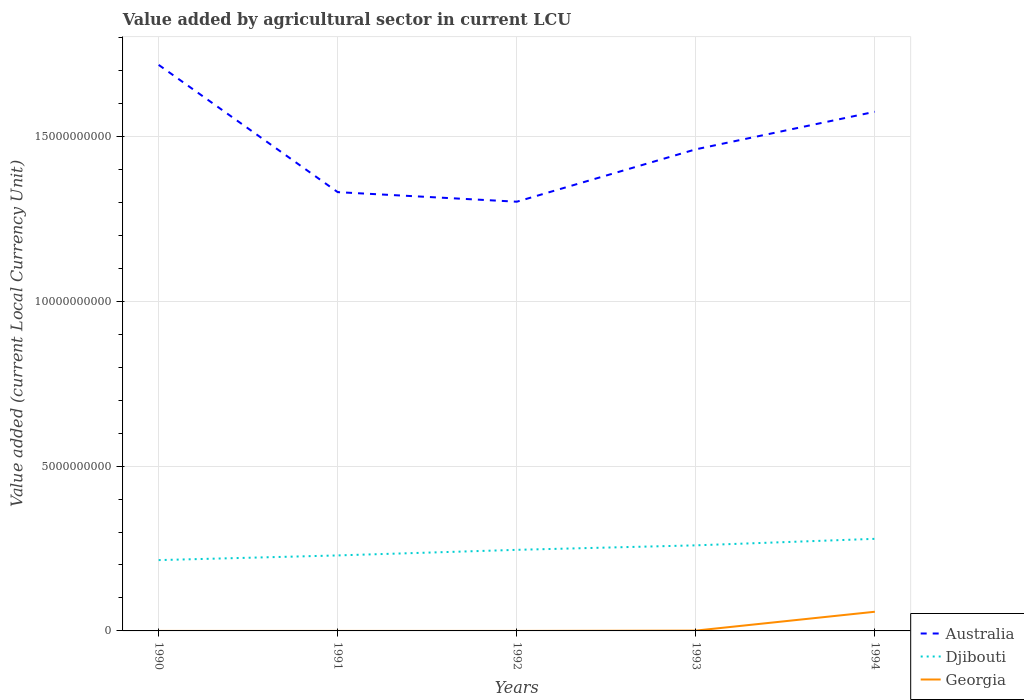How many different coloured lines are there?
Offer a very short reply. 3. Across all years, what is the maximum value added by agricultural sector in Djibouti?
Your answer should be compact. 2.15e+09. What is the total value added by agricultural sector in Georgia in the graph?
Your answer should be very brief. -5.82e+08. What is the difference between the highest and the second highest value added by agricultural sector in Australia?
Your answer should be very brief. 4.15e+09. Is the value added by agricultural sector in Australia strictly greater than the value added by agricultural sector in Djibouti over the years?
Your answer should be compact. No. How many lines are there?
Offer a very short reply. 3. Are the values on the major ticks of Y-axis written in scientific E-notation?
Offer a very short reply. No. Does the graph contain any zero values?
Your answer should be very brief. No. Does the graph contain grids?
Provide a succinct answer. Yes. Where does the legend appear in the graph?
Offer a very short reply. Bottom right. How are the legend labels stacked?
Offer a very short reply. Vertical. What is the title of the graph?
Ensure brevity in your answer.  Value added by agricultural sector in current LCU. Does "Bahrain" appear as one of the legend labels in the graph?
Give a very brief answer. No. What is the label or title of the Y-axis?
Your answer should be compact. Value added (current Local Currency Unit). What is the Value added (current Local Currency Unit) of Australia in 1990?
Ensure brevity in your answer.  1.72e+1. What is the Value added (current Local Currency Unit) in Djibouti in 1990?
Offer a very short reply. 2.15e+09. What is the Value added (current Local Currency Unit) in Georgia in 1990?
Your answer should be very brief. 4500. What is the Value added (current Local Currency Unit) of Australia in 1991?
Your answer should be compact. 1.33e+1. What is the Value added (current Local Currency Unit) in Djibouti in 1991?
Ensure brevity in your answer.  2.29e+09. What is the Value added (current Local Currency Unit) in Georgia in 1991?
Give a very brief answer. 5100. What is the Value added (current Local Currency Unit) in Australia in 1992?
Offer a terse response. 1.30e+1. What is the Value added (current Local Currency Unit) in Djibouti in 1992?
Provide a succinct answer. 2.46e+09. What is the Value added (current Local Currency Unit) of Georgia in 1992?
Keep it short and to the point. 7.81e+04. What is the Value added (current Local Currency Unit) in Australia in 1993?
Make the answer very short. 1.46e+1. What is the Value added (current Local Currency Unit) of Djibouti in 1993?
Ensure brevity in your answer.  2.60e+09. What is the Value added (current Local Currency Unit) of Georgia in 1993?
Offer a very short reply. 9.52e+06. What is the Value added (current Local Currency Unit) in Australia in 1994?
Offer a very short reply. 1.57e+1. What is the Value added (current Local Currency Unit) of Djibouti in 1994?
Provide a succinct answer. 2.79e+09. What is the Value added (current Local Currency Unit) in Georgia in 1994?
Your answer should be very brief. 5.82e+08. Across all years, what is the maximum Value added (current Local Currency Unit) in Australia?
Offer a terse response. 1.72e+1. Across all years, what is the maximum Value added (current Local Currency Unit) of Djibouti?
Your answer should be very brief. 2.79e+09. Across all years, what is the maximum Value added (current Local Currency Unit) of Georgia?
Make the answer very short. 5.82e+08. Across all years, what is the minimum Value added (current Local Currency Unit) of Australia?
Provide a succinct answer. 1.30e+1. Across all years, what is the minimum Value added (current Local Currency Unit) in Djibouti?
Offer a very short reply. 2.15e+09. Across all years, what is the minimum Value added (current Local Currency Unit) in Georgia?
Your answer should be compact. 4500. What is the total Value added (current Local Currency Unit) in Australia in the graph?
Your answer should be compact. 7.38e+1. What is the total Value added (current Local Currency Unit) of Djibouti in the graph?
Make the answer very short. 1.23e+1. What is the total Value added (current Local Currency Unit) of Georgia in the graph?
Ensure brevity in your answer.  5.91e+08. What is the difference between the Value added (current Local Currency Unit) of Australia in 1990 and that in 1991?
Offer a very short reply. 3.86e+09. What is the difference between the Value added (current Local Currency Unit) of Djibouti in 1990 and that in 1991?
Your answer should be very brief. -1.42e+08. What is the difference between the Value added (current Local Currency Unit) of Georgia in 1990 and that in 1991?
Offer a very short reply. -600. What is the difference between the Value added (current Local Currency Unit) of Australia in 1990 and that in 1992?
Provide a short and direct response. 4.15e+09. What is the difference between the Value added (current Local Currency Unit) in Djibouti in 1990 and that in 1992?
Make the answer very short. -3.11e+08. What is the difference between the Value added (current Local Currency Unit) in Georgia in 1990 and that in 1992?
Your answer should be very brief. -7.36e+04. What is the difference between the Value added (current Local Currency Unit) in Australia in 1990 and that in 1993?
Provide a succinct answer. 2.56e+09. What is the difference between the Value added (current Local Currency Unit) in Djibouti in 1990 and that in 1993?
Make the answer very short. -4.48e+08. What is the difference between the Value added (current Local Currency Unit) in Georgia in 1990 and that in 1993?
Keep it short and to the point. -9.51e+06. What is the difference between the Value added (current Local Currency Unit) in Australia in 1990 and that in 1994?
Your response must be concise. 1.42e+09. What is the difference between the Value added (current Local Currency Unit) of Djibouti in 1990 and that in 1994?
Your answer should be very brief. -6.45e+08. What is the difference between the Value added (current Local Currency Unit) in Georgia in 1990 and that in 1994?
Ensure brevity in your answer.  -5.82e+08. What is the difference between the Value added (current Local Currency Unit) in Australia in 1991 and that in 1992?
Offer a very short reply. 2.90e+08. What is the difference between the Value added (current Local Currency Unit) in Djibouti in 1991 and that in 1992?
Keep it short and to the point. -1.70e+08. What is the difference between the Value added (current Local Currency Unit) in Georgia in 1991 and that in 1992?
Offer a terse response. -7.30e+04. What is the difference between the Value added (current Local Currency Unit) of Australia in 1991 and that in 1993?
Keep it short and to the point. -1.30e+09. What is the difference between the Value added (current Local Currency Unit) of Djibouti in 1991 and that in 1993?
Your answer should be compact. -3.06e+08. What is the difference between the Value added (current Local Currency Unit) in Georgia in 1991 and that in 1993?
Give a very brief answer. -9.51e+06. What is the difference between the Value added (current Local Currency Unit) of Australia in 1991 and that in 1994?
Make the answer very short. -2.44e+09. What is the difference between the Value added (current Local Currency Unit) in Djibouti in 1991 and that in 1994?
Your answer should be very brief. -5.03e+08. What is the difference between the Value added (current Local Currency Unit) in Georgia in 1991 and that in 1994?
Offer a very short reply. -5.82e+08. What is the difference between the Value added (current Local Currency Unit) in Australia in 1992 and that in 1993?
Make the answer very short. -1.59e+09. What is the difference between the Value added (current Local Currency Unit) of Djibouti in 1992 and that in 1993?
Your answer should be compact. -1.36e+08. What is the difference between the Value added (current Local Currency Unit) of Georgia in 1992 and that in 1993?
Offer a terse response. -9.44e+06. What is the difference between the Value added (current Local Currency Unit) of Australia in 1992 and that in 1994?
Provide a succinct answer. -2.73e+09. What is the difference between the Value added (current Local Currency Unit) in Djibouti in 1992 and that in 1994?
Make the answer very short. -3.34e+08. What is the difference between the Value added (current Local Currency Unit) of Georgia in 1992 and that in 1994?
Give a very brief answer. -5.82e+08. What is the difference between the Value added (current Local Currency Unit) of Australia in 1993 and that in 1994?
Provide a succinct answer. -1.14e+09. What is the difference between the Value added (current Local Currency Unit) of Djibouti in 1993 and that in 1994?
Ensure brevity in your answer.  -1.97e+08. What is the difference between the Value added (current Local Currency Unit) in Georgia in 1993 and that in 1994?
Give a very brief answer. -5.72e+08. What is the difference between the Value added (current Local Currency Unit) in Australia in 1990 and the Value added (current Local Currency Unit) in Djibouti in 1991?
Provide a succinct answer. 1.49e+1. What is the difference between the Value added (current Local Currency Unit) in Australia in 1990 and the Value added (current Local Currency Unit) in Georgia in 1991?
Your response must be concise. 1.72e+1. What is the difference between the Value added (current Local Currency Unit) of Djibouti in 1990 and the Value added (current Local Currency Unit) of Georgia in 1991?
Offer a very short reply. 2.15e+09. What is the difference between the Value added (current Local Currency Unit) of Australia in 1990 and the Value added (current Local Currency Unit) of Djibouti in 1992?
Provide a succinct answer. 1.47e+1. What is the difference between the Value added (current Local Currency Unit) of Australia in 1990 and the Value added (current Local Currency Unit) of Georgia in 1992?
Your answer should be compact. 1.72e+1. What is the difference between the Value added (current Local Currency Unit) in Djibouti in 1990 and the Value added (current Local Currency Unit) in Georgia in 1992?
Offer a terse response. 2.15e+09. What is the difference between the Value added (current Local Currency Unit) of Australia in 1990 and the Value added (current Local Currency Unit) of Djibouti in 1993?
Offer a very short reply. 1.46e+1. What is the difference between the Value added (current Local Currency Unit) of Australia in 1990 and the Value added (current Local Currency Unit) of Georgia in 1993?
Provide a short and direct response. 1.72e+1. What is the difference between the Value added (current Local Currency Unit) of Djibouti in 1990 and the Value added (current Local Currency Unit) of Georgia in 1993?
Offer a terse response. 2.14e+09. What is the difference between the Value added (current Local Currency Unit) in Australia in 1990 and the Value added (current Local Currency Unit) in Djibouti in 1994?
Give a very brief answer. 1.44e+1. What is the difference between the Value added (current Local Currency Unit) in Australia in 1990 and the Value added (current Local Currency Unit) in Georgia in 1994?
Your response must be concise. 1.66e+1. What is the difference between the Value added (current Local Currency Unit) of Djibouti in 1990 and the Value added (current Local Currency Unit) of Georgia in 1994?
Ensure brevity in your answer.  1.57e+09. What is the difference between the Value added (current Local Currency Unit) of Australia in 1991 and the Value added (current Local Currency Unit) of Djibouti in 1992?
Give a very brief answer. 1.08e+1. What is the difference between the Value added (current Local Currency Unit) of Australia in 1991 and the Value added (current Local Currency Unit) of Georgia in 1992?
Offer a very short reply. 1.33e+1. What is the difference between the Value added (current Local Currency Unit) in Djibouti in 1991 and the Value added (current Local Currency Unit) in Georgia in 1992?
Make the answer very short. 2.29e+09. What is the difference between the Value added (current Local Currency Unit) of Australia in 1991 and the Value added (current Local Currency Unit) of Djibouti in 1993?
Your answer should be compact. 1.07e+1. What is the difference between the Value added (current Local Currency Unit) of Australia in 1991 and the Value added (current Local Currency Unit) of Georgia in 1993?
Offer a very short reply. 1.33e+1. What is the difference between the Value added (current Local Currency Unit) in Djibouti in 1991 and the Value added (current Local Currency Unit) in Georgia in 1993?
Your response must be concise. 2.28e+09. What is the difference between the Value added (current Local Currency Unit) in Australia in 1991 and the Value added (current Local Currency Unit) in Djibouti in 1994?
Provide a short and direct response. 1.05e+1. What is the difference between the Value added (current Local Currency Unit) in Australia in 1991 and the Value added (current Local Currency Unit) in Georgia in 1994?
Provide a short and direct response. 1.27e+1. What is the difference between the Value added (current Local Currency Unit) of Djibouti in 1991 and the Value added (current Local Currency Unit) of Georgia in 1994?
Provide a succinct answer. 1.71e+09. What is the difference between the Value added (current Local Currency Unit) of Australia in 1992 and the Value added (current Local Currency Unit) of Djibouti in 1993?
Keep it short and to the point. 1.04e+1. What is the difference between the Value added (current Local Currency Unit) of Australia in 1992 and the Value added (current Local Currency Unit) of Georgia in 1993?
Provide a succinct answer. 1.30e+1. What is the difference between the Value added (current Local Currency Unit) in Djibouti in 1992 and the Value added (current Local Currency Unit) in Georgia in 1993?
Provide a short and direct response. 2.45e+09. What is the difference between the Value added (current Local Currency Unit) of Australia in 1992 and the Value added (current Local Currency Unit) of Djibouti in 1994?
Offer a terse response. 1.02e+1. What is the difference between the Value added (current Local Currency Unit) of Australia in 1992 and the Value added (current Local Currency Unit) of Georgia in 1994?
Your answer should be compact. 1.24e+1. What is the difference between the Value added (current Local Currency Unit) of Djibouti in 1992 and the Value added (current Local Currency Unit) of Georgia in 1994?
Provide a short and direct response. 1.88e+09. What is the difference between the Value added (current Local Currency Unit) in Australia in 1993 and the Value added (current Local Currency Unit) in Djibouti in 1994?
Ensure brevity in your answer.  1.18e+1. What is the difference between the Value added (current Local Currency Unit) in Australia in 1993 and the Value added (current Local Currency Unit) in Georgia in 1994?
Give a very brief answer. 1.40e+1. What is the difference between the Value added (current Local Currency Unit) of Djibouti in 1993 and the Value added (current Local Currency Unit) of Georgia in 1994?
Your answer should be compact. 2.01e+09. What is the average Value added (current Local Currency Unit) in Australia per year?
Keep it short and to the point. 1.48e+1. What is the average Value added (current Local Currency Unit) of Djibouti per year?
Offer a very short reply. 2.46e+09. What is the average Value added (current Local Currency Unit) in Georgia per year?
Give a very brief answer. 1.18e+08. In the year 1990, what is the difference between the Value added (current Local Currency Unit) in Australia and Value added (current Local Currency Unit) in Djibouti?
Give a very brief answer. 1.50e+1. In the year 1990, what is the difference between the Value added (current Local Currency Unit) in Australia and Value added (current Local Currency Unit) in Georgia?
Provide a short and direct response. 1.72e+1. In the year 1990, what is the difference between the Value added (current Local Currency Unit) of Djibouti and Value added (current Local Currency Unit) of Georgia?
Make the answer very short. 2.15e+09. In the year 1991, what is the difference between the Value added (current Local Currency Unit) in Australia and Value added (current Local Currency Unit) in Djibouti?
Your answer should be very brief. 1.10e+1. In the year 1991, what is the difference between the Value added (current Local Currency Unit) in Australia and Value added (current Local Currency Unit) in Georgia?
Your answer should be compact. 1.33e+1. In the year 1991, what is the difference between the Value added (current Local Currency Unit) of Djibouti and Value added (current Local Currency Unit) of Georgia?
Provide a short and direct response. 2.29e+09. In the year 1992, what is the difference between the Value added (current Local Currency Unit) in Australia and Value added (current Local Currency Unit) in Djibouti?
Keep it short and to the point. 1.06e+1. In the year 1992, what is the difference between the Value added (current Local Currency Unit) of Australia and Value added (current Local Currency Unit) of Georgia?
Your answer should be compact. 1.30e+1. In the year 1992, what is the difference between the Value added (current Local Currency Unit) of Djibouti and Value added (current Local Currency Unit) of Georgia?
Your answer should be very brief. 2.46e+09. In the year 1993, what is the difference between the Value added (current Local Currency Unit) of Australia and Value added (current Local Currency Unit) of Djibouti?
Provide a short and direct response. 1.20e+1. In the year 1993, what is the difference between the Value added (current Local Currency Unit) in Australia and Value added (current Local Currency Unit) in Georgia?
Offer a terse response. 1.46e+1. In the year 1993, what is the difference between the Value added (current Local Currency Unit) of Djibouti and Value added (current Local Currency Unit) of Georgia?
Provide a succinct answer. 2.59e+09. In the year 1994, what is the difference between the Value added (current Local Currency Unit) in Australia and Value added (current Local Currency Unit) in Djibouti?
Give a very brief answer. 1.30e+1. In the year 1994, what is the difference between the Value added (current Local Currency Unit) in Australia and Value added (current Local Currency Unit) in Georgia?
Make the answer very short. 1.52e+1. In the year 1994, what is the difference between the Value added (current Local Currency Unit) of Djibouti and Value added (current Local Currency Unit) of Georgia?
Provide a short and direct response. 2.21e+09. What is the ratio of the Value added (current Local Currency Unit) in Australia in 1990 to that in 1991?
Provide a succinct answer. 1.29. What is the ratio of the Value added (current Local Currency Unit) of Djibouti in 1990 to that in 1991?
Offer a very short reply. 0.94. What is the ratio of the Value added (current Local Currency Unit) in Georgia in 1990 to that in 1991?
Your answer should be compact. 0.88. What is the ratio of the Value added (current Local Currency Unit) in Australia in 1990 to that in 1992?
Your response must be concise. 1.32. What is the ratio of the Value added (current Local Currency Unit) of Djibouti in 1990 to that in 1992?
Make the answer very short. 0.87. What is the ratio of the Value added (current Local Currency Unit) of Georgia in 1990 to that in 1992?
Your response must be concise. 0.06. What is the ratio of the Value added (current Local Currency Unit) of Australia in 1990 to that in 1993?
Offer a very short reply. 1.18. What is the ratio of the Value added (current Local Currency Unit) in Djibouti in 1990 to that in 1993?
Keep it short and to the point. 0.83. What is the ratio of the Value added (current Local Currency Unit) in Georgia in 1990 to that in 1993?
Your answer should be compact. 0. What is the ratio of the Value added (current Local Currency Unit) of Australia in 1990 to that in 1994?
Your answer should be compact. 1.09. What is the ratio of the Value added (current Local Currency Unit) of Djibouti in 1990 to that in 1994?
Give a very brief answer. 0.77. What is the ratio of the Value added (current Local Currency Unit) of Australia in 1991 to that in 1992?
Provide a short and direct response. 1.02. What is the ratio of the Value added (current Local Currency Unit) of Djibouti in 1991 to that in 1992?
Give a very brief answer. 0.93. What is the ratio of the Value added (current Local Currency Unit) of Georgia in 1991 to that in 1992?
Keep it short and to the point. 0.07. What is the ratio of the Value added (current Local Currency Unit) in Australia in 1991 to that in 1993?
Provide a succinct answer. 0.91. What is the ratio of the Value added (current Local Currency Unit) in Djibouti in 1991 to that in 1993?
Your answer should be compact. 0.88. What is the ratio of the Value added (current Local Currency Unit) of Australia in 1991 to that in 1994?
Your response must be concise. 0.85. What is the ratio of the Value added (current Local Currency Unit) in Djibouti in 1991 to that in 1994?
Offer a very short reply. 0.82. What is the ratio of the Value added (current Local Currency Unit) in Australia in 1992 to that in 1993?
Provide a short and direct response. 0.89. What is the ratio of the Value added (current Local Currency Unit) in Djibouti in 1992 to that in 1993?
Provide a succinct answer. 0.95. What is the ratio of the Value added (current Local Currency Unit) of Georgia in 1992 to that in 1993?
Offer a terse response. 0.01. What is the ratio of the Value added (current Local Currency Unit) of Australia in 1992 to that in 1994?
Your answer should be very brief. 0.83. What is the ratio of the Value added (current Local Currency Unit) in Djibouti in 1992 to that in 1994?
Keep it short and to the point. 0.88. What is the ratio of the Value added (current Local Currency Unit) in Georgia in 1992 to that in 1994?
Offer a very short reply. 0. What is the ratio of the Value added (current Local Currency Unit) in Australia in 1993 to that in 1994?
Make the answer very short. 0.93. What is the ratio of the Value added (current Local Currency Unit) in Djibouti in 1993 to that in 1994?
Your answer should be compact. 0.93. What is the ratio of the Value added (current Local Currency Unit) in Georgia in 1993 to that in 1994?
Your response must be concise. 0.02. What is the difference between the highest and the second highest Value added (current Local Currency Unit) in Australia?
Provide a short and direct response. 1.42e+09. What is the difference between the highest and the second highest Value added (current Local Currency Unit) of Djibouti?
Your answer should be compact. 1.97e+08. What is the difference between the highest and the second highest Value added (current Local Currency Unit) in Georgia?
Your response must be concise. 5.72e+08. What is the difference between the highest and the lowest Value added (current Local Currency Unit) in Australia?
Offer a terse response. 4.15e+09. What is the difference between the highest and the lowest Value added (current Local Currency Unit) of Djibouti?
Provide a short and direct response. 6.45e+08. What is the difference between the highest and the lowest Value added (current Local Currency Unit) in Georgia?
Your answer should be very brief. 5.82e+08. 